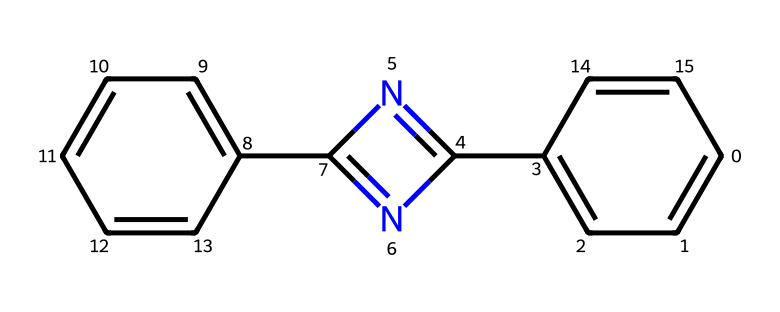What is the total number of nitrogen atoms in this compound? Analyzing the SMILES structure, I see the representation of nitrogen atoms as 'N'. There are two 'N' symbols in the structure, indicating that there are two nitrogen atoms present.
Answer: 2 How many rings are present in the chemical structure? By examining the SMILES, I can identify the ring structures indicated by the numbers. The numbers indicate connections that form rings. There are two numbers (2 and 3) suggesting the presence of two separate rings in the structure.
Answer: 2 What type of functional group is primarily present in this compound? The prominent features of the compound include a carbon-nitrogen double bond (which can be identified by the 'C(=N2)' notation) and a diene system. This suggests it is largely characterized by an imine functional group, which features a C=N bond.
Answer: imine What is the molecular framework of this compound based on its SMILES representation? The SMILES shows a series of interconnected carbon atoms forming aromatic rings and nitrogen-containing substituents. The presence of alternating double bonds defines it as an organic compound with aromatic characteristics.
Answer: aromatic Are there any substituents attached to the central carbene? From the SMILES representation, it is clear that the carbene is substituent to various groups including an imine and aromatic rings, which impacts the reactivity of the central carbene. Thus, there are substituents present.
Answer: yes What is the likely role of the carbene in photochromic reactions? Carbenes are known for their high reactivity and ability to insert into various chemical bonds. In photochromic materials, they typically play a role in switching between states when exposed to light, greatly influencing the material's properties.
Answer: reactive intermediately What kinds of transformations might this compound undergo when exposed to light? Upon light exposure, the excited state of the carbene can lead to various processes like rearrangements, cycloadditions, or dimerizations, typically altering its structure significantly and thus its functionality in photochromic dyes.
Answer: rearrangements and cycloadditions 